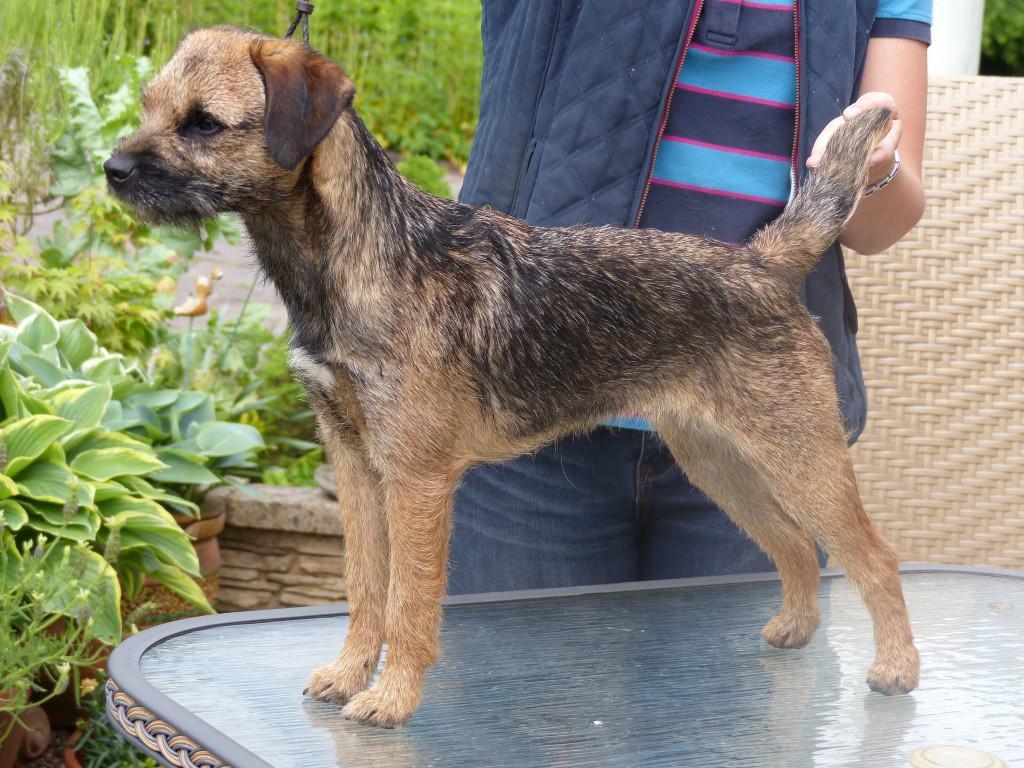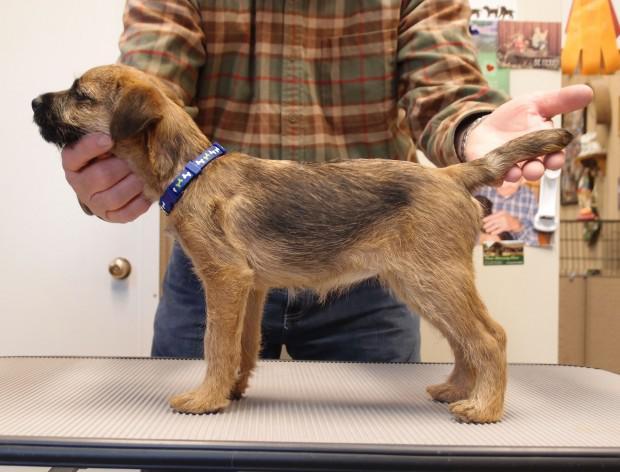The first image is the image on the left, the second image is the image on the right. Analyze the images presented: Is the assertion "There are at most two dogs." valid? Answer yes or no. Yes. The first image is the image on the left, the second image is the image on the right. Assess this claim about the two images: "Each image shows one person with exactly one dog, and one image shows a person propping the dog's chin with one hand.". Correct or not? Answer yes or no. Yes. 